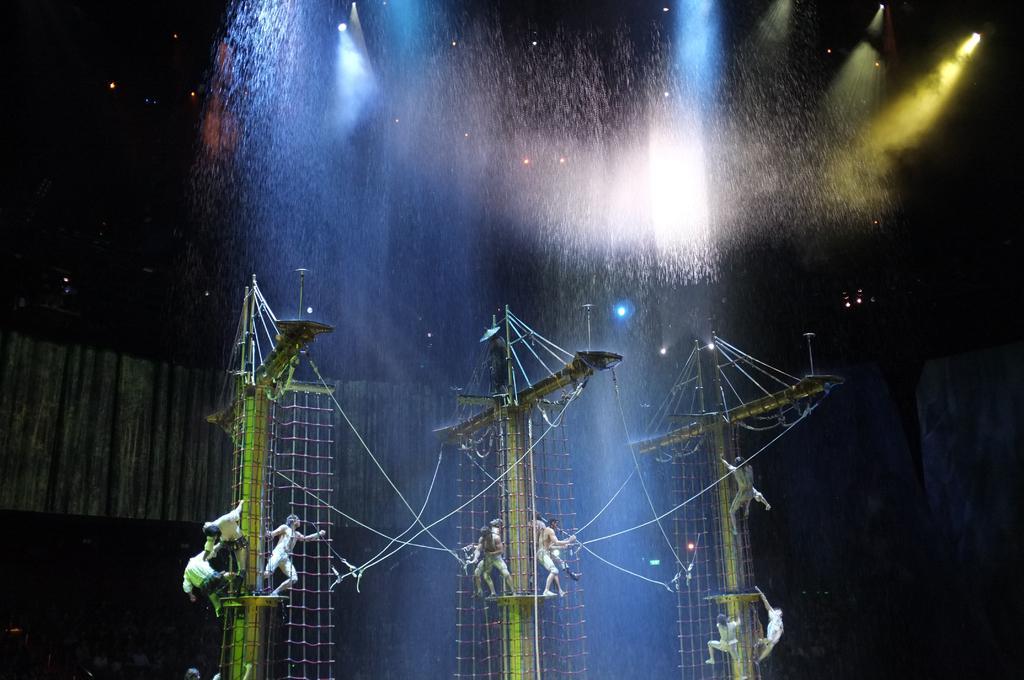Please provide a concise description of this image. In the image there are few persons standing on poles with nets on it and above there are lights, this seems to be circus. 